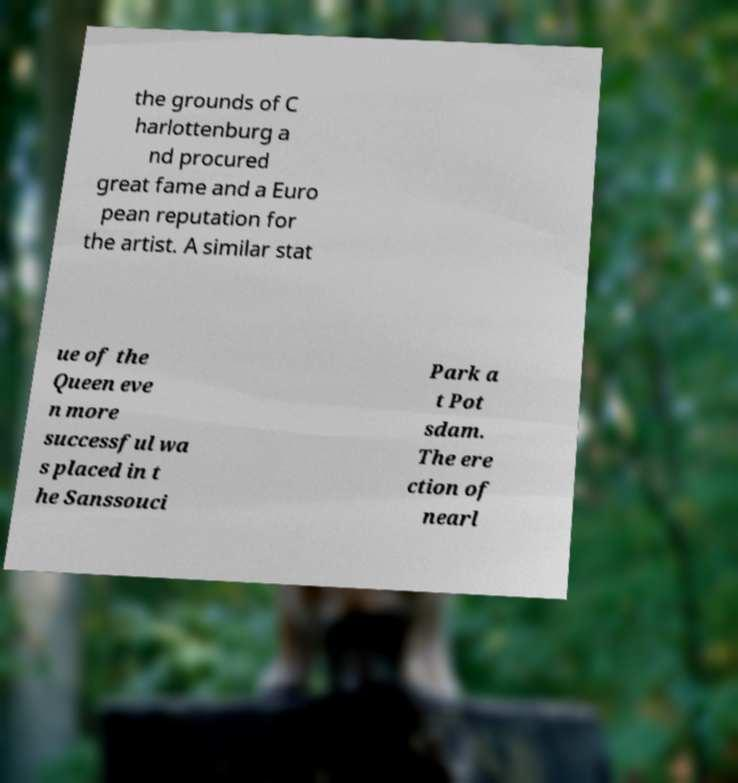What messages or text are displayed in this image? I need them in a readable, typed format. the grounds of C harlottenburg a nd procured great fame and a Euro pean reputation for the artist. A similar stat ue of the Queen eve n more successful wa s placed in t he Sanssouci Park a t Pot sdam. The ere ction of nearl 